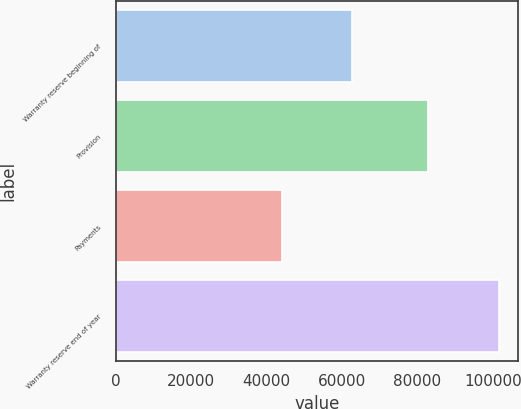Convert chart to OTSL. <chart><loc_0><loc_0><loc_500><loc_500><bar_chart><fcel>Warranty reserve beginning of<fcel>Provision<fcel>Payments<fcel>Warranty reserve end of year<nl><fcel>62742<fcel>82860<fcel>44095<fcel>101507<nl></chart> 